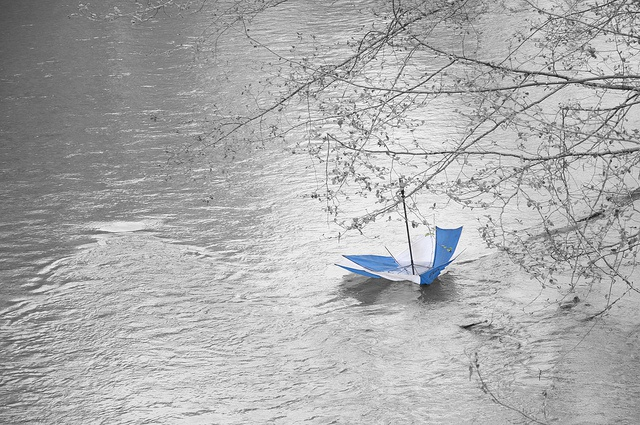Describe the objects in this image and their specific colors. I can see a umbrella in gray, lavender, and blue tones in this image. 